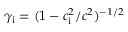<formula> <loc_0><loc_0><loc_500><loc_500>\gamma _ { i } = ( 1 - c _ { i } ^ { 2 } / c ^ { 2 } ) ^ { - 1 / 2 }</formula> 